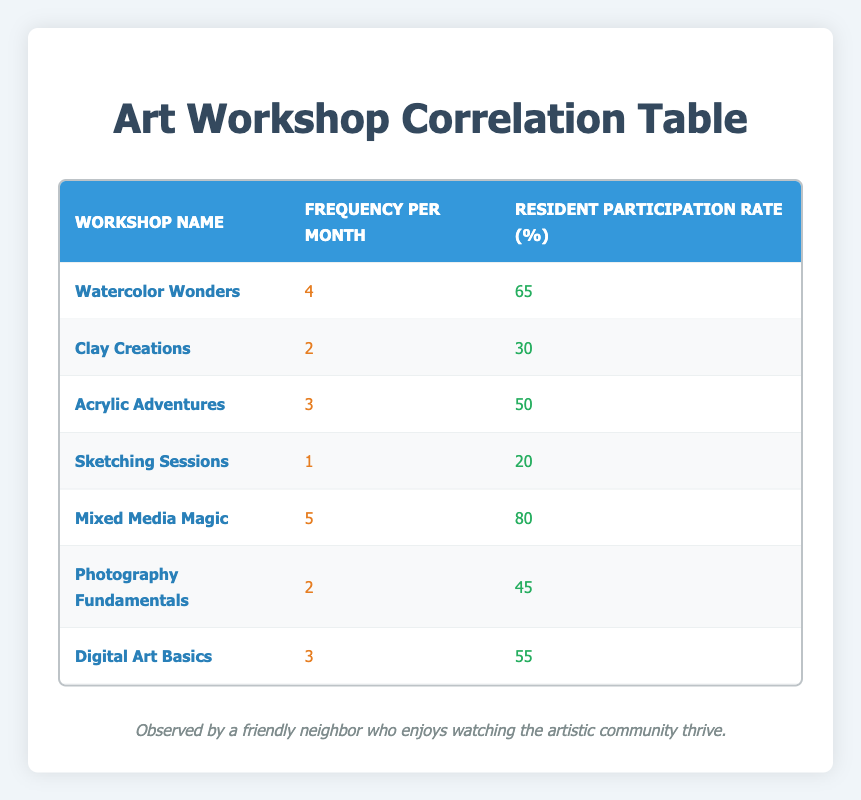What is the frequency of the "Mixed Media Magic" workshop? The table lists "Mixed Media Magic" with a frequency of 5 workshops per month under the "Frequency Per Month" column.
Answer: 5 Which workshop has the highest resident participation rate? The table indicates that "Mixed Media Magic" has the highest participation rate at 80% under the "Resident Participation Rate" column.
Answer: Mixed Media Magic What is the average frequency of all workshops? To find the average frequency, sum the frequencies: 4 + 2 + 3 + 1 + 5 + 2 + 3 = 20. There are 7 workshops, so the average is 20 divided by 7, equaling approximately 2.86.
Answer: 2.86 Is the participation rate of "Sketching Sessions" greater than that of "Clay Creations"? "Sketching Sessions" has a participation rate of 20%, while "Clay Creations" has a rate of 30%. Since 20% is less than 30%, the statement is false.
Answer: No What is the total participation rate for workshops that are held more than twice a month? The workshops held more than twice a month are: "Watercolor Wonders" (65%), "Acrylic Adventures" (50%), "Mixed Media Magic" (80%), and "Digital Art Basics" (55%). Summing these gives: 65 + 50 + 80 + 55 = 250%.
Answer: 250% How many workshops have a participation rate of at least 50%? Reviewing the table: "Watercolor Wonders" (65%), "Acrylic Adventures" (50%), "Mixed Media Magic" (80%), and "Digital Art Basics" (55%) have rates at least 50%. Totaling gives 4 workshops.
Answer: 4 What is the difference in participation rate between the highest and lowest workshop? The highest participation rate is 80% for "Mixed Media Magic" and the lowest is 20% for "Sketching Sessions." The difference is 80% - 20% = 60%.
Answer: 60 How many workshops have a frequency of less than 3 per month? The workshops with a frequency less than 3 are: "Sketching Sessions" (1), "Clay Creations" (2), and "Photography Fundamentals" (2), giving a total of 3 workshops.
Answer: 3 